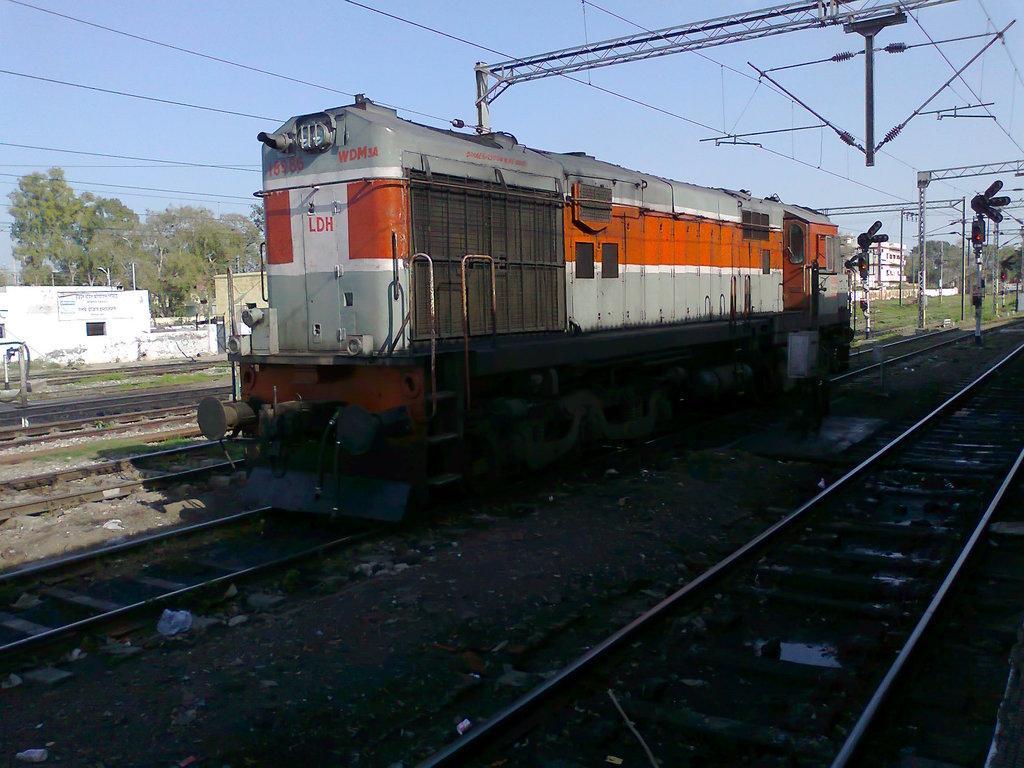Could you give a brief overview of what you see in this image? This picture is taken on the railway station. In this image, in the middle, we can see a train moving on the railway track. On the right side, we can see a traffic signal, buildings, street lights, electric wires. At the top, we can see a metal instrument, electrical wires, building. In the background, we can see a building, trees. At the top, we can see a sky, at the bottom, we can see a railway track with some stones. 